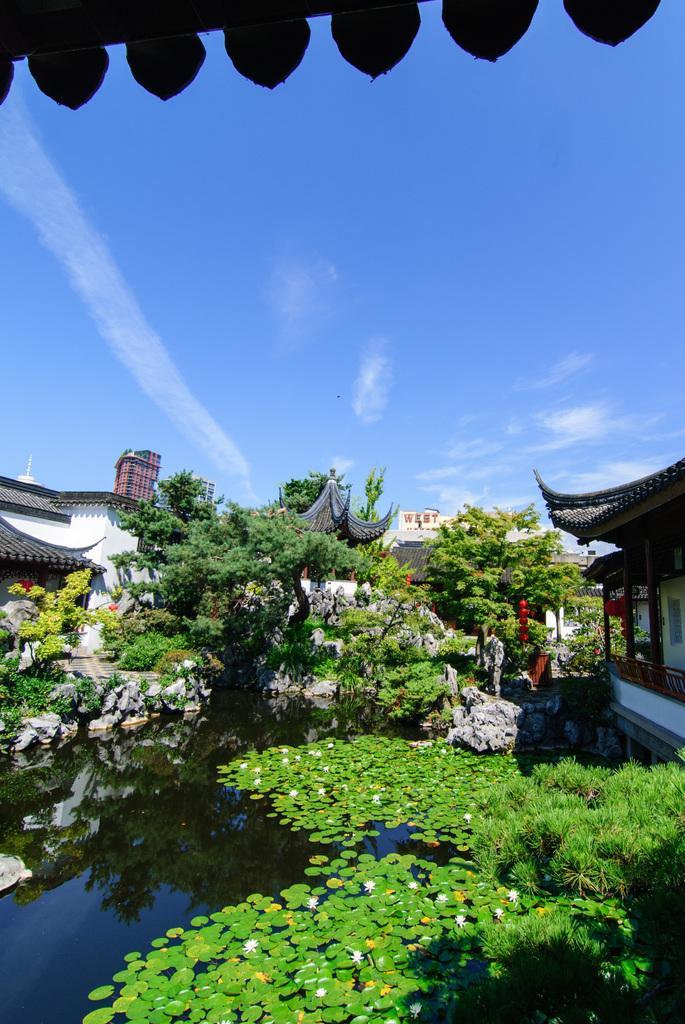How would you summarize this image in a sentence or two? In this picture, we can see a few buildings, water and some plants on it and we can see the sky with clouds. 